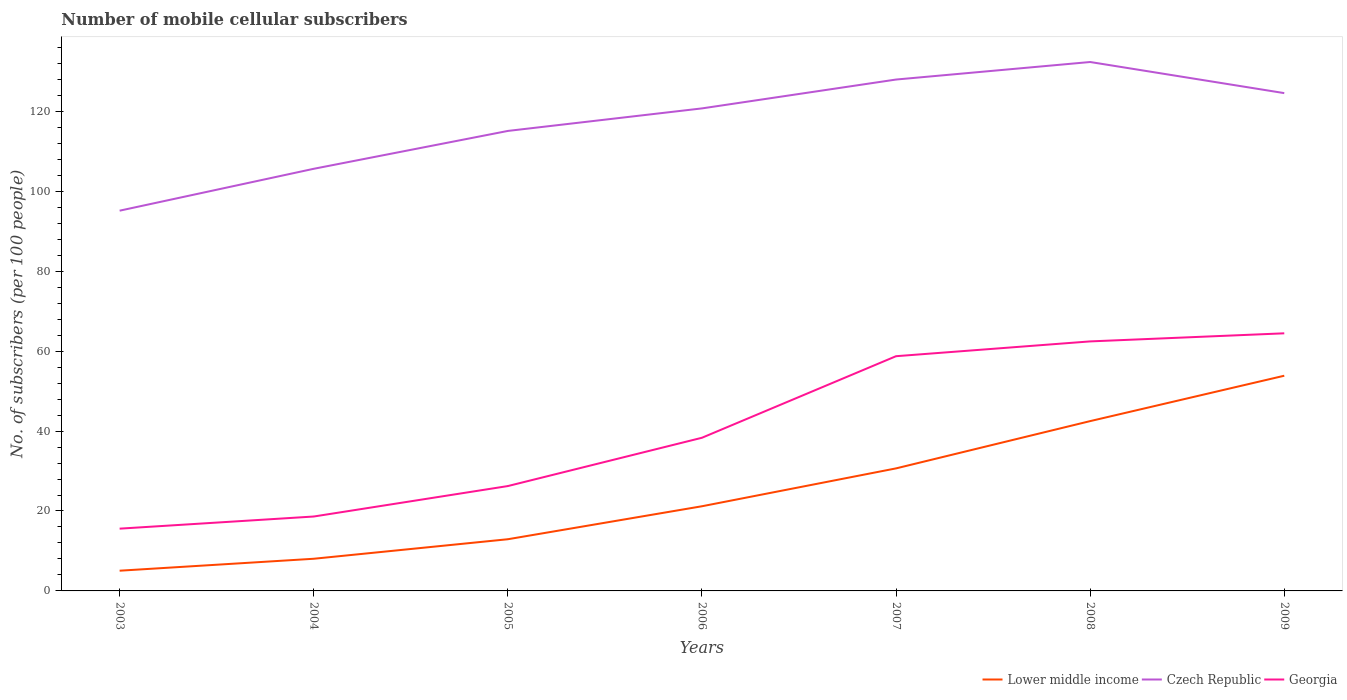Is the number of lines equal to the number of legend labels?
Keep it short and to the point. Yes. Across all years, what is the maximum number of mobile cellular subscribers in Georgia?
Make the answer very short. 15.58. In which year was the number of mobile cellular subscribers in Lower middle income maximum?
Give a very brief answer. 2003. What is the total number of mobile cellular subscribers in Czech Republic in the graph?
Offer a terse response. -10.48. What is the difference between the highest and the second highest number of mobile cellular subscribers in Czech Republic?
Ensure brevity in your answer.  37.2. What is the difference between the highest and the lowest number of mobile cellular subscribers in Czech Republic?
Ensure brevity in your answer.  4. Is the number of mobile cellular subscribers in Czech Republic strictly greater than the number of mobile cellular subscribers in Georgia over the years?
Provide a succinct answer. No. What is the difference between two consecutive major ticks on the Y-axis?
Your answer should be very brief. 20. Are the values on the major ticks of Y-axis written in scientific E-notation?
Your answer should be very brief. No. What is the title of the graph?
Offer a very short reply. Number of mobile cellular subscribers. What is the label or title of the X-axis?
Your response must be concise. Years. What is the label or title of the Y-axis?
Give a very brief answer. No. of subscribers (per 100 people). What is the No. of subscribers (per 100 people) of Lower middle income in 2003?
Ensure brevity in your answer.  5.06. What is the No. of subscribers (per 100 people) of Czech Republic in 2003?
Provide a short and direct response. 95.15. What is the No. of subscribers (per 100 people) in Georgia in 2003?
Make the answer very short. 15.58. What is the No. of subscribers (per 100 people) in Lower middle income in 2004?
Your answer should be compact. 8.05. What is the No. of subscribers (per 100 people) in Czech Republic in 2004?
Provide a short and direct response. 105.63. What is the No. of subscribers (per 100 people) in Georgia in 2004?
Your answer should be very brief. 18.62. What is the No. of subscribers (per 100 people) in Lower middle income in 2005?
Give a very brief answer. 12.93. What is the No. of subscribers (per 100 people) of Czech Republic in 2005?
Your response must be concise. 115.1. What is the No. of subscribers (per 100 people) of Georgia in 2005?
Your response must be concise. 26.24. What is the No. of subscribers (per 100 people) in Lower middle income in 2006?
Ensure brevity in your answer.  21.19. What is the No. of subscribers (per 100 people) in Czech Republic in 2006?
Your answer should be compact. 120.74. What is the No. of subscribers (per 100 people) in Georgia in 2006?
Your answer should be compact. 38.32. What is the No. of subscribers (per 100 people) in Lower middle income in 2007?
Offer a very short reply. 30.66. What is the No. of subscribers (per 100 people) in Czech Republic in 2007?
Your answer should be compact. 127.96. What is the No. of subscribers (per 100 people) of Georgia in 2007?
Offer a very short reply. 58.74. What is the No. of subscribers (per 100 people) of Lower middle income in 2008?
Ensure brevity in your answer.  42.49. What is the No. of subscribers (per 100 people) of Czech Republic in 2008?
Ensure brevity in your answer.  132.35. What is the No. of subscribers (per 100 people) in Georgia in 2008?
Ensure brevity in your answer.  62.44. What is the No. of subscribers (per 100 people) in Lower middle income in 2009?
Offer a very short reply. 53.85. What is the No. of subscribers (per 100 people) of Czech Republic in 2009?
Make the answer very short. 124.57. What is the No. of subscribers (per 100 people) of Georgia in 2009?
Your response must be concise. 64.46. Across all years, what is the maximum No. of subscribers (per 100 people) in Lower middle income?
Provide a short and direct response. 53.85. Across all years, what is the maximum No. of subscribers (per 100 people) of Czech Republic?
Offer a terse response. 132.35. Across all years, what is the maximum No. of subscribers (per 100 people) of Georgia?
Ensure brevity in your answer.  64.46. Across all years, what is the minimum No. of subscribers (per 100 people) of Lower middle income?
Provide a short and direct response. 5.06. Across all years, what is the minimum No. of subscribers (per 100 people) of Czech Republic?
Keep it short and to the point. 95.15. Across all years, what is the minimum No. of subscribers (per 100 people) of Georgia?
Provide a succinct answer. 15.58. What is the total No. of subscribers (per 100 people) of Lower middle income in the graph?
Keep it short and to the point. 174.23. What is the total No. of subscribers (per 100 people) of Czech Republic in the graph?
Offer a terse response. 821.51. What is the total No. of subscribers (per 100 people) of Georgia in the graph?
Your answer should be compact. 284.4. What is the difference between the No. of subscribers (per 100 people) of Lower middle income in 2003 and that in 2004?
Provide a succinct answer. -2.99. What is the difference between the No. of subscribers (per 100 people) of Czech Republic in 2003 and that in 2004?
Your response must be concise. -10.48. What is the difference between the No. of subscribers (per 100 people) of Georgia in 2003 and that in 2004?
Your answer should be very brief. -3.04. What is the difference between the No. of subscribers (per 100 people) in Lower middle income in 2003 and that in 2005?
Provide a short and direct response. -7.87. What is the difference between the No. of subscribers (per 100 people) of Czech Republic in 2003 and that in 2005?
Your answer should be very brief. -19.96. What is the difference between the No. of subscribers (per 100 people) of Georgia in 2003 and that in 2005?
Keep it short and to the point. -10.66. What is the difference between the No. of subscribers (per 100 people) in Lower middle income in 2003 and that in 2006?
Offer a very short reply. -16.13. What is the difference between the No. of subscribers (per 100 people) in Czech Republic in 2003 and that in 2006?
Keep it short and to the point. -25.6. What is the difference between the No. of subscribers (per 100 people) in Georgia in 2003 and that in 2006?
Keep it short and to the point. -22.74. What is the difference between the No. of subscribers (per 100 people) of Lower middle income in 2003 and that in 2007?
Your answer should be very brief. -25.6. What is the difference between the No. of subscribers (per 100 people) in Czech Republic in 2003 and that in 2007?
Make the answer very short. -32.82. What is the difference between the No. of subscribers (per 100 people) of Georgia in 2003 and that in 2007?
Offer a very short reply. -43.16. What is the difference between the No. of subscribers (per 100 people) of Lower middle income in 2003 and that in 2008?
Offer a terse response. -37.43. What is the difference between the No. of subscribers (per 100 people) in Czech Republic in 2003 and that in 2008?
Your answer should be very brief. -37.2. What is the difference between the No. of subscribers (per 100 people) in Georgia in 2003 and that in 2008?
Provide a succinct answer. -46.86. What is the difference between the No. of subscribers (per 100 people) in Lower middle income in 2003 and that in 2009?
Make the answer very short. -48.79. What is the difference between the No. of subscribers (per 100 people) in Czech Republic in 2003 and that in 2009?
Provide a succinct answer. -29.42. What is the difference between the No. of subscribers (per 100 people) in Georgia in 2003 and that in 2009?
Provide a short and direct response. -48.88. What is the difference between the No. of subscribers (per 100 people) in Lower middle income in 2004 and that in 2005?
Make the answer very short. -4.89. What is the difference between the No. of subscribers (per 100 people) of Czech Republic in 2004 and that in 2005?
Make the answer very short. -9.47. What is the difference between the No. of subscribers (per 100 people) of Georgia in 2004 and that in 2005?
Your response must be concise. -7.62. What is the difference between the No. of subscribers (per 100 people) in Lower middle income in 2004 and that in 2006?
Your response must be concise. -13.14. What is the difference between the No. of subscribers (per 100 people) in Czech Republic in 2004 and that in 2006?
Keep it short and to the point. -15.11. What is the difference between the No. of subscribers (per 100 people) of Georgia in 2004 and that in 2006?
Make the answer very short. -19.71. What is the difference between the No. of subscribers (per 100 people) of Lower middle income in 2004 and that in 2007?
Keep it short and to the point. -22.61. What is the difference between the No. of subscribers (per 100 people) of Czech Republic in 2004 and that in 2007?
Ensure brevity in your answer.  -22.33. What is the difference between the No. of subscribers (per 100 people) of Georgia in 2004 and that in 2007?
Offer a terse response. -40.12. What is the difference between the No. of subscribers (per 100 people) in Lower middle income in 2004 and that in 2008?
Your answer should be compact. -34.44. What is the difference between the No. of subscribers (per 100 people) of Czech Republic in 2004 and that in 2008?
Keep it short and to the point. -26.72. What is the difference between the No. of subscribers (per 100 people) in Georgia in 2004 and that in 2008?
Keep it short and to the point. -43.82. What is the difference between the No. of subscribers (per 100 people) in Lower middle income in 2004 and that in 2009?
Provide a succinct answer. -45.8. What is the difference between the No. of subscribers (per 100 people) in Czech Republic in 2004 and that in 2009?
Offer a very short reply. -18.94. What is the difference between the No. of subscribers (per 100 people) in Georgia in 2004 and that in 2009?
Provide a succinct answer. -45.84. What is the difference between the No. of subscribers (per 100 people) in Lower middle income in 2005 and that in 2006?
Offer a terse response. -8.25. What is the difference between the No. of subscribers (per 100 people) in Czech Republic in 2005 and that in 2006?
Your answer should be compact. -5.64. What is the difference between the No. of subscribers (per 100 people) of Georgia in 2005 and that in 2006?
Your answer should be compact. -12.08. What is the difference between the No. of subscribers (per 100 people) of Lower middle income in 2005 and that in 2007?
Provide a short and direct response. -17.73. What is the difference between the No. of subscribers (per 100 people) in Czech Republic in 2005 and that in 2007?
Your answer should be compact. -12.86. What is the difference between the No. of subscribers (per 100 people) in Georgia in 2005 and that in 2007?
Make the answer very short. -32.5. What is the difference between the No. of subscribers (per 100 people) of Lower middle income in 2005 and that in 2008?
Your answer should be very brief. -29.56. What is the difference between the No. of subscribers (per 100 people) of Czech Republic in 2005 and that in 2008?
Your answer should be compact. -17.25. What is the difference between the No. of subscribers (per 100 people) of Georgia in 2005 and that in 2008?
Your answer should be compact. -36.2. What is the difference between the No. of subscribers (per 100 people) of Lower middle income in 2005 and that in 2009?
Give a very brief answer. -40.91. What is the difference between the No. of subscribers (per 100 people) in Czech Republic in 2005 and that in 2009?
Provide a succinct answer. -9.46. What is the difference between the No. of subscribers (per 100 people) of Georgia in 2005 and that in 2009?
Offer a terse response. -38.22. What is the difference between the No. of subscribers (per 100 people) in Lower middle income in 2006 and that in 2007?
Keep it short and to the point. -9.48. What is the difference between the No. of subscribers (per 100 people) of Czech Republic in 2006 and that in 2007?
Provide a succinct answer. -7.22. What is the difference between the No. of subscribers (per 100 people) of Georgia in 2006 and that in 2007?
Keep it short and to the point. -20.41. What is the difference between the No. of subscribers (per 100 people) of Lower middle income in 2006 and that in 2008?
Your response must be concise. -21.31. What is the difference between the No. of subscribers (per 100 people) in Czech Republic in 2006 and that in 2008?
Your answer should be very brief. -11.61. What is the difference between the No. of subscribers (per 100 people) of Georgia in 2006 and that in 2008?
Your answer should be compact. -24.11. What is the difference between the No. of subscribers (per 100 people) in Lower middle income in 2006 and that in 2009?
Offer a terse response. -32.66. What is the difference between the No. of subscribers (per 100 people) of Czech Republic in 2006 and that in 2009?
Offer a terse response. -3.82. What is the difference between the No. of subscribers (per 100 people) in Georgia in 2006 and that in 2009?
Give a very brief answer. -26.14. What is the difference between the No. of subscribers (per 100 people) in Lower middle income in 2007 and that in 2008?
Make the answer very short. -11.83. What is the difference between the No. of subscribers (per 100 people) of Czech Republic in 2007 and that in 2008?
Your response must be concise. -4.39. What is the difference between the No. of subscribers (per 100 people) of Georgia in 2007 and that in 2008?
Provide a short and direct response. -3.7. What is the difference between the No. of subscribers (per 100 people) of Lower middle income in 2007 and that in 2009?
Keep it short and to the point. -23.18. What is the difference between the No. of subscribers (per 100 people) in Czech Republic in 2007 and that in 2009?
Ensure brevity in your answer.  3.4. What is the difference between the No. of subscribers (per 100 people) in Georgia in 2007 and that in 2009?
Your answer should be very brief. -5.72. What is the difference between the No. of subscribers (per 100 people) in Lower middle income in 2008 and that in 2009?
Provide a short and direct response. -11.36. What is the difference between the No. of subscribers (per 100 people) of Czech Republic in 2008 and that in 2009?
Offer a very short reply. 7.78. What is the difference between the No. of subscribers (per 100 people) of Georgia in 2008 and that in 2009?
Your answer should be compact. -2.02. What is the difference between the No. of subscribers (per 100 people) in Lower middle income in 2003 and the No. of subscribers (per 100 people) in Czech Republic in 2004?
Provide a short and direct response. -100.57. What is the difference between the No. of subscribers (per 100 people) of Lower middle income in 2003 and the No. of subscribers (per 100 people) of Georgia in 2004?
Provide a succinct answer. -13.56. What is the difference between the No. of subscribers (per 100 people) in Czech Republic in 2003 and the No. of subscribers (per 100 people) in Georgia in 2004?
Offer a terse response. 76.53. What is the difference between the No. of subscribers (per 100 people) in Lower middle income in 2003 and the No. of subscribers (per 100 people) in Czech Republic in 2005?
Give a very brief answer. -110.04. What is the difference between the No. of subscribers (per 100 people) of Lower middle income in 2003 and the No. of subscribers (per 100 people) of Georgia in 2005?
Offer a terse response. -21.18. What is the difference between the No. of subscribers (per 100 people) of Czech Republic in 2003 and the No. of subscribers (per 100 people) of Georgia in 2005?
Give a very brief answer. 68.91. What is the difference between the No. of subscribers (per 100 people) of Lower middle income in 2003 and the No. of subscribers (per 100 people) of Czech Republic in 2006?
Your answer should be compact. -115.68. What is the difference between the No. of subscribers (per 100 people) in Lower middle income in 2003 and the No. of subscribers (per 100 people) in Georgia in 2006?
Offer a very short reply. -33.26. What is the difference between the No. of subscribers (per 100 people) in Czech Republic in 2003 and the No. of subscribers (per 100 people) in Georgia in 2006?
Make the answer very short. 56.82. What is the difference between the No. of subscribers (per 100 people) in Lower middle income in 2003 and the No. of subscribers (per 100 people) in Czech Republic in 2007?
Your answer should be compact. -122.9. What is the difference between the No. of subscribers (per 100 people) in Lower middle income in 2003 and the No. of subscribers (per 100 people) in Georgia in 2007?
Give a very brief answer. -53.68. What is the difference between the No. of subscribers (per 100 people) in Czech Republic in 2003 and the No. of subscribers (per 100 people) in Georgia in 2007?
Ensure brevity in your answer.  36.41. What is the difference between the No. of subscribers (per 100 people) in Lower middle income in 2003 and the No. of subscribers (per 100 people) in Czech Republic in 2008?
Your answer should be compact. -127.29. What is the difference between the No. of subscribers (per 100 people) of Lower middle income in 2003 and the No. of subscribers (per 100 people) of Georgia in 2008?
Offer a terse response. -57.38. What is the difference between the No. of subscribers (per 100 people) of Czech Republic in 2003 and the No. of subscribers (per 100 people) of Georgia in 2008?
Make the answer very short. 32.71. What is the difference between the No. of subscribers (per 100 people) in Lower middle income in 2003 and the No. of subscribers (per 100 people) in Czech Republic in 2009?
Give a very brief answer. -119.51. What is the difference between the No. of subscribers (per 100 people) of Lower middle income in 2003 and the No. of subscribers (per 100 people) of Georgia in 2009?
Keep it short and to the point. -59.4. What is the difference between the No. of subscribers (per 100 people) of Czech Republic in 2003 and the No. of subscribers (per 100 people) of Georgia in 2009?
Give a very brief answer. 30.69. What is the difference between the No. of subscribers (per 100 people) in Lower middle income in 2004 and the No. of subscribers (per 100 people) in Czech Republic in 2005?
Keep it short and to the point. -107.05. What is the difference between the No. of subscribers (per 100 people) of Lower middle income in 2004 and the No. of subscribers (per 100 people) of Georgia in 2005?
Offer a terse response. -18.19. What is the difference between the No. of subscribers (per 100 people) of Czech Republic in 2004 and the No. of subscribers (per 100 people) of Georgia in 2005?
Your answer should be compact. 79.39. What is the difference between the No. of subscribers (per 100 people) in Lower middle income in 2004 and the No. of subscribers (per 100 people) in Czech Republic in 2006?
Keep it short and to the point. -112.69. What is the difference between the No. of subscribers (per 100 people) in Lower middle income in 2004 and the No. of subscribers (per 100 people) in Georgia in 2006?
Provide a short and direct response. -30.27. What is the difference between the No. of subscribers (per 100 people) of Czech Republic in 2004 and the No. of subscribers (per 100 people) of Georgia in 2006?
Make the answer very short. 67.31. What is the difference between the No. of subscribers (per 100 people) in Lower middle income in 2004 and the No. of subscribers (per 100 people) in Czech Republic in 2007?
Offer a very short reply. -119.92. What is the difference between the No. of subscribers (per 100 people) in Lower middle income in 2004 and the No. of subscribers (per 100 people) in Georgia in 2007?
Make the answer very short. -50.69. What is the difference between the No. of subscribers (per 100 people) of Czech Republic in 2004 and the No. of subscribers (per 100 people) of Georgia in 2007?
Keep it short and to the point. 46.89. What is the difference between the No. of subscribers (per 100 people) in Lower middle income in 2004 and the No. of subscribers (per 100 people) in Czech Republic in 2008?
Provide a short and direct response. -124.3. What is the difference between the No. of subscribers (per 100 people) of Lower middle income in 2004 and the No. of subscribers (per 100 people) of Georgia in 2008?
Keep it short and to the point. -54.39. What is the difference between the No. of subscribers (per 100 people) in Czech Republic in 2004 and the No. of subscribers (per 100 people) in Georgia in 2008?
Make the answer very short. 43.19. What is the difference between the No. of subscribers (per 100 people) in Lower middle income in 2004 and the No. of subscribers (per 100 people) in Czech Republic in 2009?
Your answer should be very brief. -116.52. What is the difference between the No. of subscribers (per 100 people) in Lower middle income in 2004 and the No. of subscribers (per 100 people) in Georgia in 2009?
Offer a terse response. -56.41. What is the difference between the No. of subscribers (per 100 people) in Czech Republic in 2004 and the No. of subscribers (per 100 people) in Georgia in 2009?
Provide a succinct answer. 41.17. What is the difference between the No. of subscribers (per 100 people) of Lower middle income in 2005 and the No. of subscribers (per 100 people) of Czech Republic in 2006?
Offer a very short reply. -107.81. What is the difference between the No. of subscribers (per 100 people) of Lower middle income in 2005 and the No. of subscribers (per 100 people) of Georgia in 2006?
Offer a terse response. -25.39. What is the difference between the No. of subscribers (per 100 people) of Czech Republic in 2005 and the No. of subscribers (per 100 people) of Georgia in 2006?
Make the answer very short. 76.78. What is the difference between the No. of subscribers (per 100 people) in Lower middle income in 2005 and the No. of subscribers (per 100 people) in Czech Republic in 2007?
Provide a short and direct response. -115.03. What is the difference between the No. of subscribers (per 100 people) in Lower middle income in 2005 and the No. of subscribers (per 100 people) in Georgia in 2007?
Ensure brevity in your answer.  -45.8. What is the difference between the No. of subscribers (per 100 people) of Czech Republic in 2005 and the No. of subscribers (per 100 people) of Georgia in 2007?
Offer a terse response. 56.37. What is the difference between the No. of subscribers (per 100 people) in Lower middle income in 2005 and the No. of subscribers (per 100 people) in Czech Republic in 2008?
Ensure brevity in your answer.  -119.42. What is the difference between the No. of subscribers (per 100 people) in Lower middle income in 2005 and the No. of subscribers (per 100 people) in Georgia in 2008?
Your response must be concise. -49.5. What is the difference between the No. of subscribers (per 100 people) in Czech Republic in 2005 and the No. of subscribers (per 100 people) in Georgia in 2008?
Provide a short and direct response. 52.67. What is the difference between the No. of subscribers (per 100 people) in Lower middle income in 2005 and the No. of subscribers (per 100 people) in Czech Republic in 2009?
Offer a terse response. -111.63. What is the difference between the No. of subscribers (per 100 people) of Lower middle income in 2005 and the No. of subscribers (per 100 people) of Georgia in 2009?
Make the answer very short. -51.53. What is the difference between the No. of subscribers (per 100 people) in Czech Republic in 2005 and the No. of subscribers (per 100 people) in Georgia in 2009?
Your answer should be compact. 50.64. What is the difference between the No. of subscribers (per 100 people) in Lower middle income in 2006 and the No. of subscribers (per 100 people) in Czech Republic in 2007?
Your answer should be compact. -106.78. What is the difference between the No. of subscribers (per 100 people) in Lower middle income in 2006 and the No. of subscribers (per 100 people) in Georgia in 2007?
Give a very brief answer. -37.55. What is the difference between the No. of subscribers (per 100 people) in Czech Republic in 2006 and the No. of subscribers (per 100 people) in Georgia in 2007?
Keep it short and to the point. 62.01. What is the difference between the No. of subscribers (per 100 people) of Lower middle income in 2006 and the No. of subscribers (per 100 people) of Czech Republic in 2008?
Offer a very short reply. -111.17. What is the difference between the No. of subscribers (per 100 people) of Lower middle income in 2006 and the No. of subscribers (per 100 people) of Georgia in 2008?
Provide a succinct answer. -41.25. What is the difference between the No. of subscribers (per 100 people) of Czech Republic in 2006 and the No. of subscribers (per 100 people) of Georgia in 2008?
Make the answer very short. 58.3. What is the difference between the No. of subscribers (per 100 people) in Lower middle income in 2006 and the No. of subscribers (per 100 people) in Czech Republic in 2009?
Keep it short and to the point. -103.38. What is the difference between the No. of subscribers (per 100 people) in Lower middle income in 2006 and the No. of subscribers (per 100 people) in Georgia in 2009?
Offer a very short reply. -43.28. What is the difference between the No. of subscribers (per 100 people) of Czech Republic in 2006 and the No. of subscribers (per 100 people) of Georgia in 2009?
Provide a short and direct response. 56.28. What is the difference between the No. of subscribers (per 100 people) in Lower middle income in 2007 and the No. of subscribers (per 100 people) in Czech Republic in 2008?
Make the answer very short. -101.69. What is the difference between the No. of subscribers (per 100 people) in Lower middle income in 2007 and the No. of subscribers (per 100 people) in Georgia in 2008?
Offer a very short reply. -31.78. What is the difference between the No. of subscribers (per 100 people) of Czech Republic in 2007 and the No. of subscribers (per 100 people) of Georgia in 2008?
Ensure brevity in your answer.  65.53. What is the difference between the No. of subscribers (per 100 people) of Lower middle income in 2007 and the No. of subscribers (per 100 people) of Czech Republic in 2009?
Your answer should be very brief. -93.9. What is the difference between the No. of subscribers (per 100 people) in Lower middle income in 2007 and the No. of subscribers (per 100 people) in Georgia in 2009?
Give a very brief answer. -33.8. What is the difference between the No. of subscribers (per 100 people) in Czech Republic in 2007 and the No. of subscribers (per 100 people) in Georgia in 2009?
Provide a short and direct response. 63.5. What is the difference between the No. of subscribers (per 100 people) in Lower middle income in 2008 and the No. of subscribers (per 100 people) in Czech Republic in 2009?
Offer a very short reply. -82.07. What is the difference between the No. of subscribers (per 100 people) of Lower middle income in 2008 and the No. of subscribers (per 100 people) of Georgia in 2009?
Offer a very short reply. -21.97. What is the difference between the No. of subscribers (per 100 people) of Czech Republic in 2008 and the No. of subscribers (per 100 people) of Georgia in 2009?
Give a very brief answer. 67.89. What is the average No. of subscribers (per 100 people) of Lower middle income per year?
Ensure brevity in your answer.  24.89. What is the average No. of subscribers (per 100 people) in Czech Republic per year?
Offer a terse response. 117.36. What is the average No. of subscribers (per 100 people) of Georgia per year?
Give a very brief answer. 40.63. In the year 2003, what is the difference between the No. of subscribers (per 100 people) in Lower middle income and No. of subscribers (per 100 people) in Czech Republic?
Keep it short and to the point. -90.09. In the year 2003, what is the difference between the No. of subscribers (per 100 people) in Lower middle income and No. of subscribers (per 100 people) in Georgia?
Your answer should be compact. -10.52. In the year 2003, what is the difference between the No. of subscribers (per 100 people) in Czech Republic and No. of subscribers (per 100 people) in Georgia?
Give a very brief answer. 79.57. In the year 2004, what is the difference between the No. of subscribers (per 100 people) of Lower middle income and No. of subscribers (per 100 people) of Czech Republic?
Provide a short and direct response. -97.58. In the year 2004, what is the difference between the No. of subscribers (per 100 people) of Lower middle income and No. of subscribers (per 100 people) of Georgia?
Make the answer very short. -10.57. In the year 2004, what is the difference between the No. of subscribers (per 100 people) in Czech Republic and No. of subscribers (per 100 people) in Georgia?
Make the answer very short. 87.01. In the year 2005, what is the difference between the No. of subscribers (per 100 people) in Lower middle income and No. of subscribers (per 100 people) in Czech Republic?
Provide a short and direct response. -102.17. In the year 2005, what is the difference between the No. of subscribers (per 100 people) in Lower middle income and No. of subscribers (per 100 people) in Georgia?
Provide a short and direct response. -13.31. In the year 2005, what is the difference between the No. of subscribers (per 100 people) in Czech Republic and No. of subscribers (per 100 people) in Georgia?
Your answer should be compact. 88.86. In the year 2006, what is the difference between the No. of subscribers (per 100 people) of Lower middle income and No. of subscribers (per 100 people) of Czech Republic?
Provide a short and direct response. -99.56. In the year 2006, what is the difference between the No. of subscribers (per 100 people) of Lower middle income and No. of subscribers (per 100 people) of Georgia?
Offer a terse response. -17.14. In the year 2006, what is the difference between the No. of subscribers (per 100 people) in Czech Republic and No. of subscribers (per 100 people) in Georgia?
Your response must be concise. 82.42. In the year 2007, what is the difference between the No. of subscribers (per 100 people) in Lower middle income and No. of subscribers (per 100 people) in Czech Republic?
Keep it short and to the point. -97.3. In the year 2007, what is the difference between the No. of subscribers (per 100 people) in Lower middle income and No. of subscribers (per 100 people) in Georgia?
Keep it short and to the point. -28.07. In the year 2007, what is the difference between the No. of subscribers (per 100 people) in Czech Republic and No. of subscribers (per 100 people) in Georgia?
Your response must be concise. 69.23. In the year 2008, what is the difference between the No. of subscribers (per 100 people) in Lower middle income and No. of subscribers (per 100 people) in Czech Republic?
Provide a short and direct response. -89.86. In the year 2008, what is the difference between the No. of subscribers (per 100 people) in Lower middle income and No. of subscribers (per 100 people) in Georgia?
Offer a very short reply. -19.95. In the year 2008, what is the difference between the No. of subscribers (per 100 people) of Czech Republic and No. of subscribers (per 100 people) of Georgia?
Provide a short and direct response. 69.91. In the year 2009, what is the difference between the No. of subscribers (per 100 people) in Lower middle income and No. of subscribers (per 100 people) in Czech Republic?
Offer a very short reply. -70.72. In the year 2009, what is the difference between the No. of subscribers (per 100 people) in Lower middle income and No. of subscribers (per 100 people) in Georgia?
Offer a terse response. -10.61. In the year 2009, what is the difference between the No. of subscribers (per 100 people) of Czech Republic and No. of subscribers (per 100 people) of Georgia?
Your response must be concise. 60.11. What is the ratio of the No. of subscribers (per 100 people) of Lower middle income in 2003 to that in 2004?
Offer a very short reply. 0.63. What is the ratio of the No. of subscribers (per 100 people) of Czech Republic in 2003 to that in 2004?
Your answer should be very brief. 0.9. What is the ratio of the No. of subscribers (per 100 people) in Georgia in 2003 to that in 2004?
Give a very brief answer. 0.84. What is the ratio of the No. of subscribers (per 100 people) in Lower middle income in 2003 to that in 2005?
Your answer should be compact. 0.39. What is the ratio of the No. of subscribers (per 100 people) in Czech Republic in 2003 to that in 2005?
Make the answer very short. 0.83. What is the ratio of the No. of subscribers (per 100 people) in Georgia in 2003 to that in 2005?
Give a very brief answer. 0.59. What is the ratio of the No. of subscribers (per 100 people) in Lower middle income in 2003 to that in 2006?
Offer a terse response. 0.24. What is the ratio of the No. of subscribers (per 100 people) of Czech Republic in 2003 to that in 2006?
Ensure brevity in your answer.  0.79. What is the ratio of the No. of subscribers (per 100 people) of Georgia in 2003 to that in 2006?
Your response must be concise. 0.41. What is the ratio of the No. of subscribers (per 100 people) of Lower middle income in 2003 to that in 2007?
Provide a succinct answer. 0.17. What is the ratio of the No. of subscribers (per 100 people) of Czech Republic in 2003 to that in 2007?
Your answer should be very brief. 0.74. What is the ratio of the No. of subscribers (per 100 people) of Georgia in 2003 to that in 2007?
Offer a terse response. 0.27. What is the ratio of the No. of subscribers (per 100 people) of Lower middle income in 2003 to that in 2008?
Your response must be concise. 0.12. What is the ratio of the No. of subscribers (per 100 people) of Czech Republic in 2003 to that in 2008?
Give a very brief answer. 0.72. What is the ratio of the No. of subscribers (per 100 people) in Georgia in 2003 to that in 2008?
Provide a short and direct response. 0.25. What is the ratio of the No. of subscribers (per 100 people) in Lower middle income in 2003 to that in 2009?
Make the answer very short. 0.09. What is the ratio of the No. of subscribers (per 100 people) in Czech Republic in 2003 to that in 2009?
Provide a short and direct response. 0.76. What is the ratio of the No. of subscribers (per 100 people) in Georgia in 2003 to that in 2009?
Your answer should be very brief. 0.24. What is the ratio of the No. of subscribers (per 100 people) in Lower middle income in 2004 to that in 2005?
Your response must be concise. 0.62. What is the ratio of the No. of subscribers (per 100 people) of Czech Republic in 2004 to that in 2005?
Provide a short and direct response. 0.92. What is the ratio of the No. of subscribers (per 100 people) in Georgia in 2004 to that in 2005?
Offer a terse response. 0.71. What is the ratio of the No. of subscribers (per 100 people) of Lower middle income in 2004 to that in 2006?
Your answer should be very brief. 0.38. What is the ratio of the No. of subscribers (per 100 people) of Czech Republic in 2004 to that in 2006?
Provide a short and direct response. 0.87. What is the ratio of the No. of subscribers (per 100 people) in Georgia in 2004 to that in 2006?
Your response must be concise. 0.49. What is the ratio of the No. of subscribers (per 100 people) in Lower middle income in 2004 to that in 2007?
Keep it short and to the point. 0.26. What is the ratio of the No. of subscribers (per 100 people) of Czech Republic in 2004 to that in 2007?
Provide a succinct answer. 0.83. What is the ratio of the No. of subscribers (per 100 people) in Georgia in 2004 to that in 2007?
Provide a short and direct response. 0.32. What is the ratio of the No. of subscribers (per 100 people) in Lower middle income in 2004 to that in 2008?
Provide a succinct answer. 0.19. What is the ratio of the No. of subscribers (per 100 people) of Czech Republic in 2004 to that in 2008?
Ensure brevity in your answer.  0.8. What is the ratio of the No. of subscribers (per 100 people) in Georgia in 2004 to that in 2008?
Give a very brief answer. 0.3. What is the ratio of the No. of subscribers (per 100 people) in Lower middle income in 2004 to that in 2009?
Provide a succinct answer. 0.15. What is the ratio of the No. of subscribers (per 100 people) in Czech Republic in 2004 to that in 2009?
Your response must be concise. 0.85. What is the ratio of the No. of subscribers (per 100 people) in Georgia in 2004 to that in 2009?
Your answer should be compact. 0.29. What is the ratio of the No. of subscribers (per 100 people) in Lower middle income in 2005 to that in 2006?
Give a very brief answer. 0.61. What is the ratio of the No. of subscribers (per 100 people) of Czech Republic in 2005 to that in 2006?
Offer a terse response. 0.95. What is the ratio of the No. of subscribers (per 100 people) of Georgia in 2005 to that in 2006?
Your answer should be compact. 0.68. What is the ratio of the No. of subscribers (per 100 people) of Lower middle income in 2005 to that in 2007?
Ensure brevity in your answer.  0.42. What is the ratio of the No. of subscribers (per 100 people) of Czech Republic in 2005 to that in 2007?
Give a very brief answer. 0.9. What is the ratio of the No. of subscribers (per 100 people) in Georgia in 2005 to that in 2007?
Provide a short and direct response. 0.45. What is the ratio of the No. of subscribers (per 100 people) of Lower middle income in 2005 to that in 2008?
Ensure brevity in your answer.  0.3. What is the ratio of the No. of subscribers (per 100 people) in Czech Republic in 2005 to that in 2008?
Provide a succinct answer. 0.87. What is the ratio of the No. of subscribers (per 100 people) in Georgia in 2005 to that in 2008?
Give a very brief answer. 0.42. What is the ratio of the No. of subscribers (per 100 people) of Lower middle income in 2005 to that in 2009?
Offer a very short reply. 0.24. What is the ratio of the No. of subscribers (per 100 people) in Czech Republic in 2005 to that in 2009?
Offer a terse response. 0.92. What is the ratio of the No. of subscribers (per 100 people) of Georgia in 2005 to that in 2009?
Provide a succinct answer. 0.41. What is the ratio of the No. of subscribers (per 100 people) in Lower middle income in 2006 to that in 2007?
Your answer should be very brief. 0.69. What is the ratio of the No. of subscribers (per 100 people) in Czech Republic in 2006 to that in 2007?
Provide a succinct answer. 0.94. What is the ratio of the No. of subscribers (per 100 people) of Georgia in 2006 to that in 2007?
Your response must be concise. 0.65. What is the ratio of the No. of subscribers (per 100 people) in Lower middle income in 2006 to that in 2008?
Ensure brevity in your answer.  0.5. What is the ratio of the No. of subscribers (per 100 people) of Czech Republic in 2006 to that in 2008?
Your answer should be very brief. 0.91. What is the ratio of the No. of subscribers (per 100 people) of Georgia in 2006 to that in 2008?
Provide a succinct answer. 0.61. What is the ratio of the No. of subscribers (per 100 people) in Lower middle income in 2006 to that in 2009?
Provide a succinct answer. 0.39. What is the ratio of the No. of subscribers (per 100 people) in Czech Republic in 2006 to that in 2009?
Your response must be concise. 0.97. What is the ratio of the No. of subscribers (per 100 people) of Georgia in 2006 to that in 2009?
Offer a terse response. 0.59. What is the ratio of the No. of subscribers (per 100 people) of Lower middle income in 2007 to that in 2008?
Ensure brevity in your answer.  0.72. What is the ratio of the No. of subscribers (per 100 people) of Czech Republic in 2007 to that in 2008?
Your response must be concise. 0.97. What is the ratio of the No. of subscribers (per 100 people) in Georgia in 2007 to that in 2008?
Provide a short and direct response. 0.94. What is the ratio of the No. of subscribers (per 100 people) of Lower middle income in 2007 to that in 2009?
Your answer should be very brief. 0.57. What is the ratio of the No. of subscribers (per 100 people) in Czech Republic in 2007 to that in 2009?
Keep it short and to the point. 1.03. What is the ratio of the No. of subscribers (per 100 people) of Georgia in 2007 to that in 2009?
Provide a short and direct response. 0.91. What is the ratio of the No. of subscribers (per 100 people) of Lower middle income in 2008 to that in 2009?
Offer a terse response. 0.79. What is the ratio of the No. of subscribers (per 100 people) in Georgia in 2008 to that in 2009?
Provide a succinct answer. 0.97. What is the difference between the highest and the second highest No. of subscribers (per 100 people) in Lower middle income?
Provide a succinct answer. 11.36. What is the difference between the highest and the second highest No. of subscribers (per 100 people) in Czech Republic?
Your answer should be very brief. 4.39. What is the difference between the highest and the second highest No. of subscribers (per 100 people) in Georgia?
Your answer should be very brief. 2.02. What is the difference between the highest and the lowest No. of subscribers (per 100 people) of Lower middle income?
Give a very brief answer. 48.79. What is the difference between the highest and the lowest No. of subscribers (per 100 people) in Czech Republic?
Keep it short and to the point. 37.2. What is the difference between the highest and the lowest No. of subscribers (per 100 people) in Georgia?
Your answer should be very brief. 48.88. 